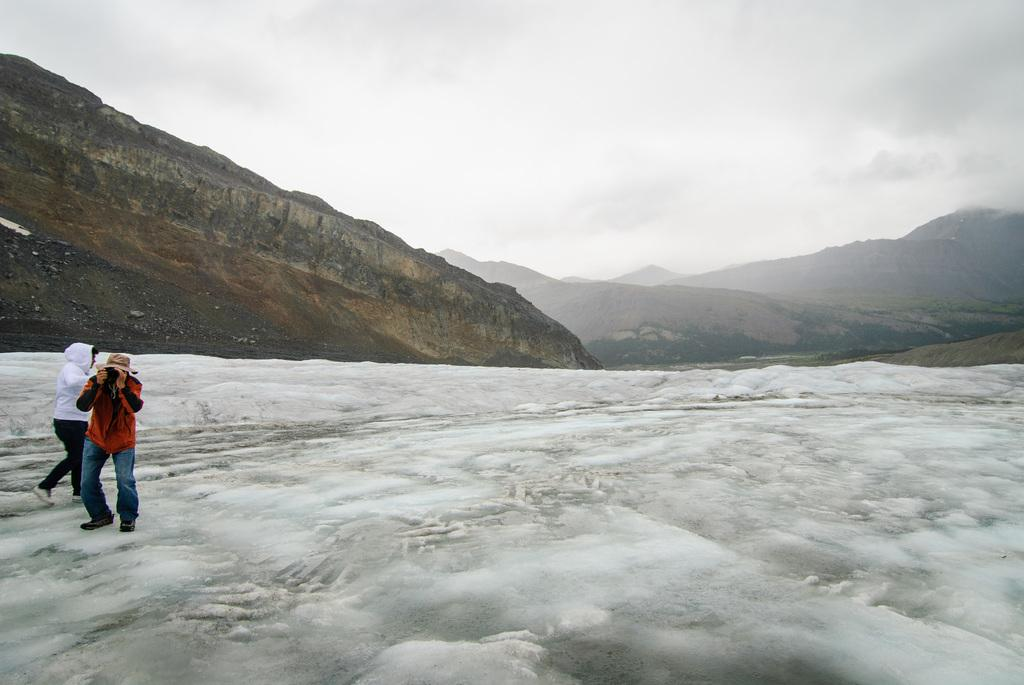How many people are in the image? There are two persons standing on the snow. What is one of the persons holding? One person is holding a camera. What can be seen in the distance behind the people? There are hills visible in the background. What is visible above the hills and people? The sky is visible in the background. What type of jail can be seen in the image? There is no jail present in the image. What effect does the snow have on the engine of the vehicle in the image? There is no vehicle or engine present in the image. 